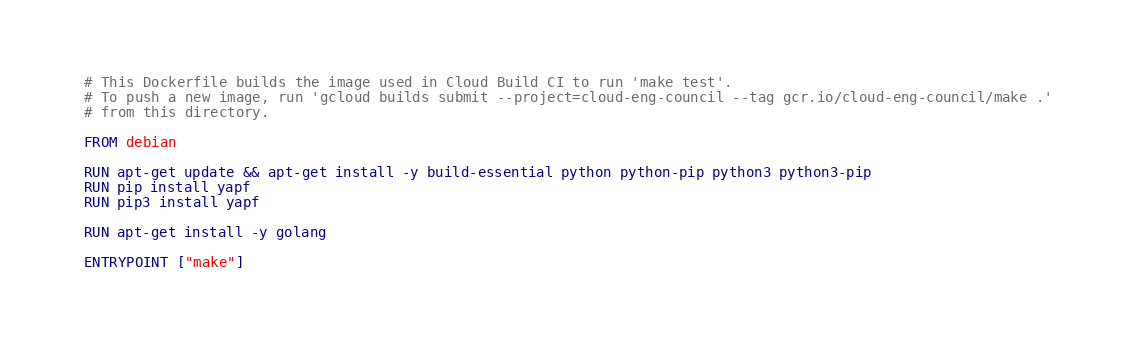<code> <loc_0><loc_0><loc_500><loc_500><_Dockerfile_># This Dockerfile builds the image used in Cloud Build CI to run 'make test'.
# To push a new image, run 'gcloud builds submit --project=cloud-eng-council --tag gcr.io/cloud-eng-council/make .'
# from this directory.

FROM debian

RUN apt-get update && apt-get install -y build-essential python python-pip python3 python3-pip
RUN pip install yapf
RUN pip3 install yapf

RUN apt-get install -y golang

ENTRYPOINT ["make"]
</code> 